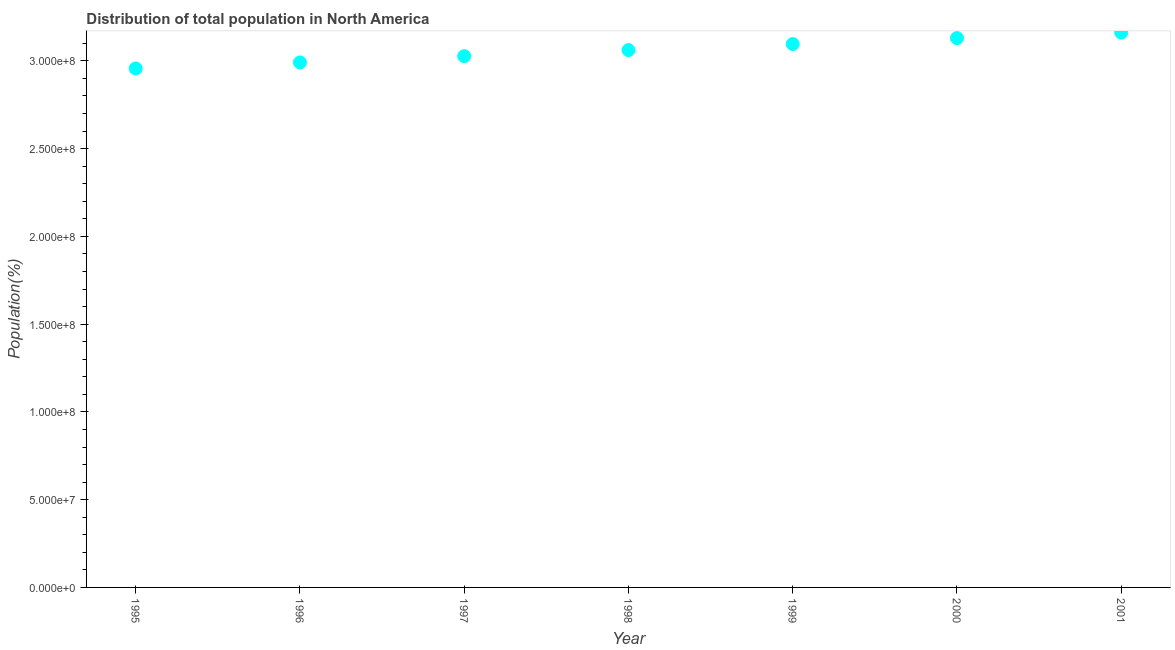What is the population in 1999?
Keep it short and to the point. 3.10e+08. Across all years, what is the maximum population?
Offer a very short reply. 3.16e+08. Across all years, what is the minimum population?
Ensure brevity in your answer.  2.96e+08. In which year was the population maximum?
Offer a very short reply. 2001. What is the sum of the population?
Provide a short and direct response. 2.14e+09. What is the difference between the population in 1996 and 2001?
Ensure brevity in your answer.  -1.70e+07. What is the average population per year?
Offer a very short reply. 3.06e+08. What is the median population?
Keep it short and to the point. 3.06e+08. What is the ratio of the population in 1997 to that in 2001?
Ensure brevity in your answer.  0.96. Is the population in 1995 less than that in 2001?
Your answer should be compact. Yes. Is the difference between the population in 1997 and 1999 greater than the difference between any two years?
Make the answer very short. No. What is the difference between the highest and the second highest population?
Provide a short and direct response. 3.12e+06. Is the sum of the population in 1997 and 2001 greater than the maximum population across all years?
Your answer should be compact. Yes. What is the difference between the highest and the lowest population?
Keep it short and to the point. 2.04e+07. In how many years, is the population greater than the average population taken over all years?
Ensure brevity in your answer.  4. How many dotlines are there?
Your answer should be very brief. 1. How many years are there in the graph?
Make the answer very short. 7. Are the values on the major ticks of Y-axis written in scientific E-notation?
Give a very brief answer. Yes. What is the title of the graph?
Make the answer very short. Distribution of total population in North America . What is the label or title of the Y-axis?
Ensure brevity in your answer.  Population(%). What is the Population(%) in 1995?
Your answer should be compact. 2.96e+08. What is the Population(%) in 1996?
Your response must be concise. 2.99e+08. What is the Population(%) in 1997?
Make the answer very short. 3.03e+08. What is the Population(%) in 1998?
Ensure brevity in your answer.  3.06e+08. What is the Population(%) in 1999?
Your response must be concise. 3.10e+08. What is the Population(%) in 2000?
Give a very brief answer. 3.13e+08. What is the Population(%) in 2001?
Offer a very short reply. 3.16e+08. What is the difference between the Population(%) in 1995 and 1996?
Your response must be concise. -3.43e+06. What is the difference between the Population(%) in 1995 and 1997?
Provide a succinct answer. -7.01e+06. What is the difference between the Population(%) in 1995 and 1998?
Your answer should be very brief. -1.05e+07. What is the difference between the Population(%) in 1995 and 1999?
Give a very brief answer. -1.39e+07. What is the difference between the Population(%) in 1995 and 2000?
Provide a succinct answer. -1.73e+07. What is the difference between the Population(%) in 1995 and 2001?
Provide a short and direct response. -2.04e+07. What is the difference between the Population(%) in 1996 and 1997?
Provide a succinct answer. -3.58e+06. What is the difference between the Population(%) in 1996 and 1998?
Keep it short and to the point. -7.04e+06. What is the difference between the Population(%) in 1996 and 1999?
Provide a short and direct response. -1.05e+07. What is the difference between the Population(%) in 1996 and 2000?
Your answer should be compact. -1.39e+07. What is the difference between the Population(%) in 1996 and 2001?
Provide a succinct answer. -1.70e+07. What is the difference between the Population(%) in 1997 and 1998?
Ensure brevity in your answer.  -3.46e+06. What is the difference between the Population(%) in 1997 and 1999?
Keep it short and to the point. -6.90e+06. What is the difference between the Population(%) in 1997 and 2000?
Your answer should be very brief. -1.03e+07. What is the difference between the Population(%) in 1997 and 2001?
Make the answer very short. -1.34e+07. What is the difference between the Population(%) in 1998 and 1999?
Your response must be concise. -3.44e+06. What is the difference between the Population(%) in 1998 and 2000?
Provide a short and direct response. -6.83e+06. What is the difference between the Population(%) in 1998 and 2001?
Give a very brief answer. -9.95e+06. What is the difference between the Population(%) in 1999 and 2000?
Ensure brevity in your answer.  -3.39e+06. What is the difference between the Population(%) in 1999 and 2001?
Offer a very short reply. -6.51e+06. What is the difference between the Population(%) in 2000 and 2001?
Keep it short and to the point. -3.12e+06. What is the ratio of the Population(%) in 1995 to that in 1997?
Provide a succinct answer. 0.98. What is the ratio of the Population(%) in 1995 to that in 1999?
Ensure brevity in your answer.  0.95. What is the ratio of the Population(%) in 1995 to that in 2000?
Offer a terse response. 0.94. What is the ratio of the Population(%) in 1995 to that in 2001?
Give a very brief answer. 0.94. What is the ratio of the Population(%) in 1996 to that in 2000?
Make the answer very short. 0.96. What is the ratio of the Population(%) in 1996 to that in 2001?
Your response must be concise. 0.95. What is the ratio of the Population(%) in 1997 to that in 1998?
Make the answer very short. 0.99. What is the ratio of the Population(%) in 1997 to that in 1999?
Provide a succinct answer. 0.98. What is the ratio of the Population(%) in 1997 to that in 2001?
Offer a very short reply. 0.96. What is the ratio of the Population(%) in 1998 to that in 1999?
Your response must be concise. 0.99. What is the ratio of the Population(%) in 1998 to that in 2001?
Make the answer very short. 0.97. What is the ratio of the Population(%) in 1999 to that in 2000?
Provide a short and direct response. 0.99. What is the ratio of the Population(%) in 2000 to that in 2001?
Your answer should be compact. 0.99. 